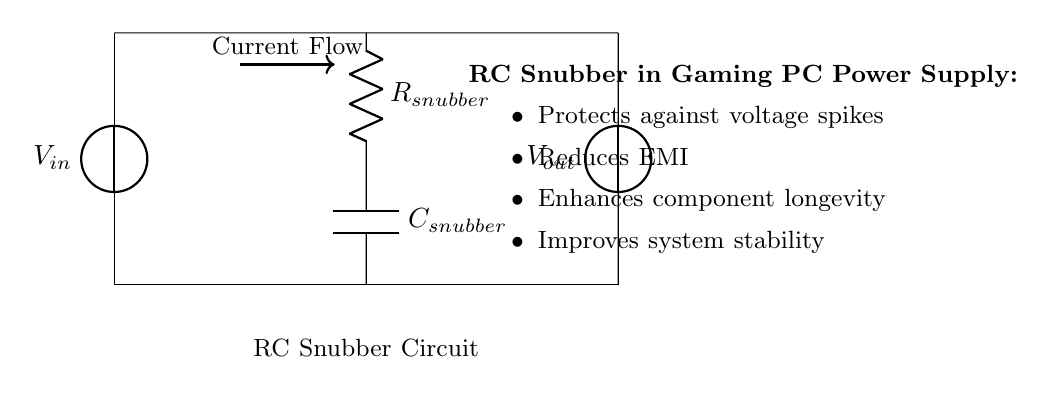What is the input voltage of this circuit? The input voltage is marked as V in the diagram at the left side, indicating that it is the source voltage provided to the circuit.
Answer: V in What component reduces voltage spikes? The component responsible for reducing voltage spikes in this circuit is the capacitor labeled C snubber, which helps absorb excess voltage during transient events.
Answer: C snubber How is the resistor positioned in the circuit? The resistor labeled R snubber is connected in series with the capacitor. Its layout is vertically aligned and signifies its role in the RC snubber circuit configuration.
Answer: Series with C snubber What is the primary function of this RC snubber circuit? The primary function is to protect against voltage spikes, as indicated in the description that highlights the benefits of employing this circuit within power supplies of gaming PCs.
Answer: Protect against voltage spikes What effect does the snubber circuit have on electromagnetic interference? The snubber circuit reduces electromagnetic interference (EMI) as it aids in stabilizing the voltage by smoothing out fluctuations caused by spikes, thereby enhancing the overall functioning of the power supply.
Answer: Reduces EMI How does the RC snubber enhance component longevity? The RC snubber enhances component longevity by mitigating voltage spikes and reducing stress on electrical components, which prolongs their operational lifespan and reliability in gaming PCs.
Answer: Prolongs lifespan 